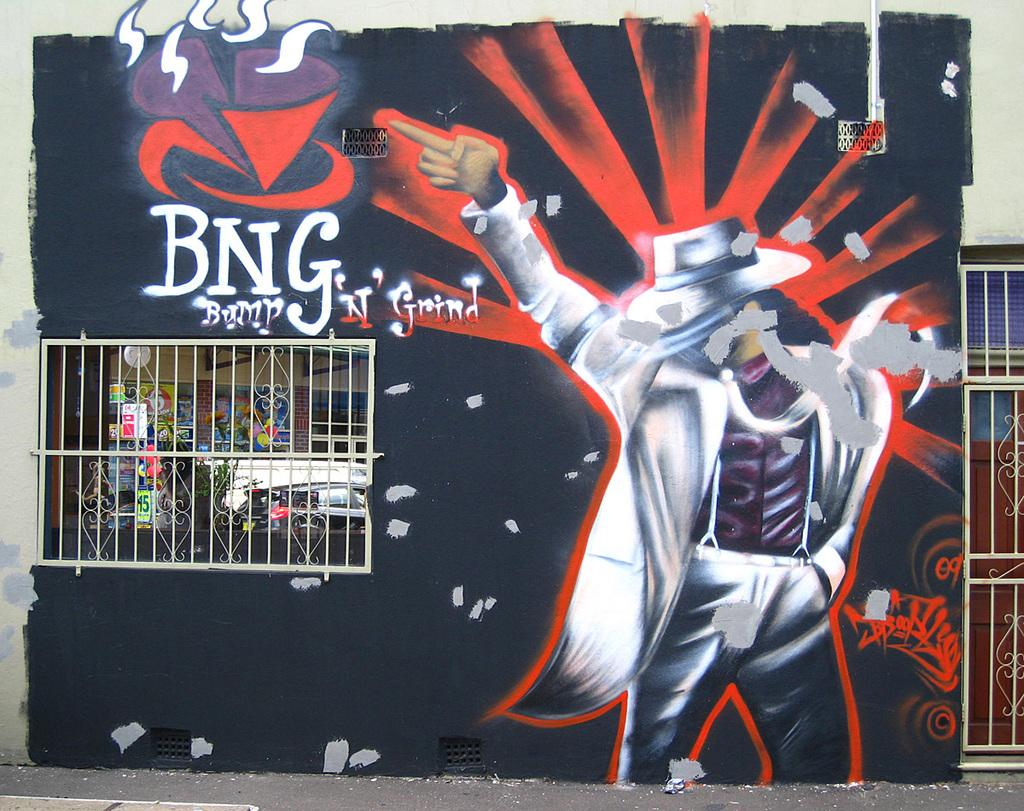<image>
Render a clear and concise summary of the photo. Graffiti wall art of a performer and the words BNG bump n' grind 